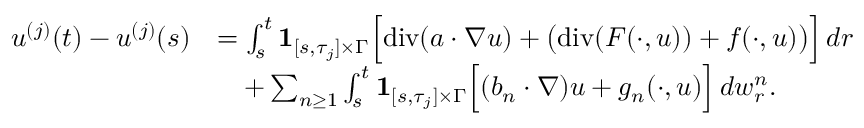<formula> <loc_0><loc_0><loc_500><loc_500>\begin{array} { r l } { u ^ { ( j ) } ( t ) - u ^ { ( j ) } ( s ) } & { = \int _ { s } ^ { t } { 1 } _ { [ s , \tau _ { j } ] \times \Gamma } \left [ { d i v } ( a \cdot \nabla u ) + \left ( { d i v } ( F ( \cdot , u ) ) + f ( \cdot , u ) \right ) \right ] \, d r } \\ & { \quad + \sum _ { n \geq 1 } \int _ { s } ^ { t } { 1 } _ { [ s , \tau _ { j } ] \times \Gamma } \left [ ( b _ { n } \cdot \nabla ) u + g _ { n } ( \cdot , u ) \right ] \, d w _ { r } ^ { n } . } \end{array}</formula> 